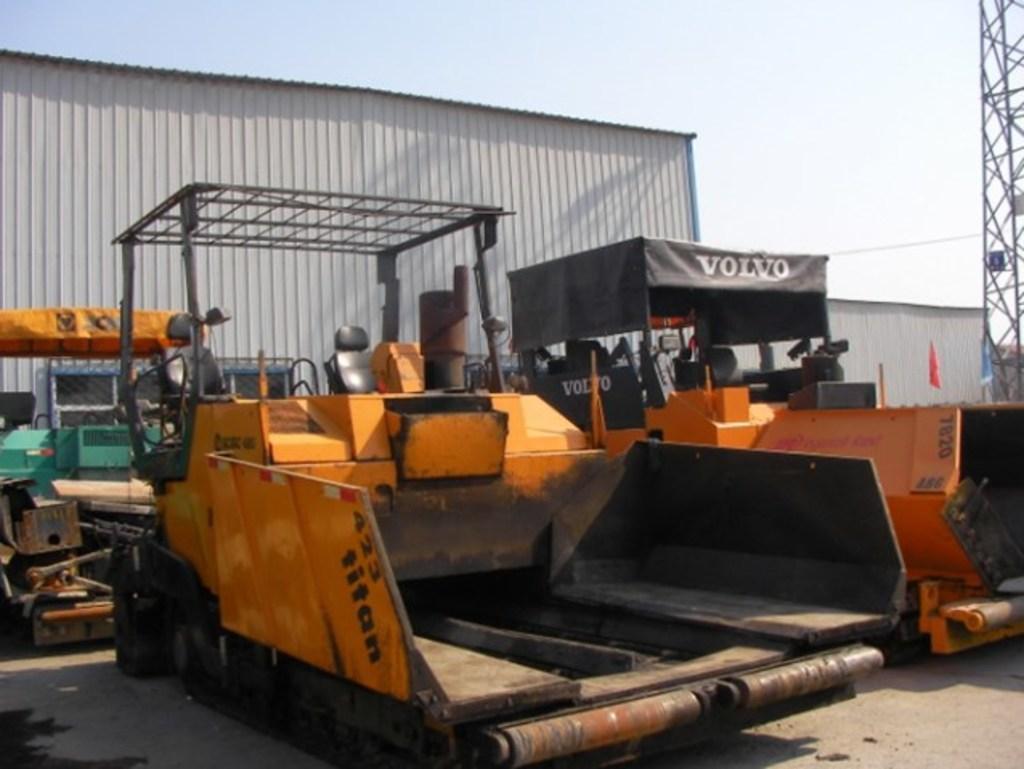Can you describe this image briefly? In this picture there are vehicles and there is text on the vehicle. At the back there is a building and there are flags and there is a tower. At the top there is sky. At the bottom there is a road. 